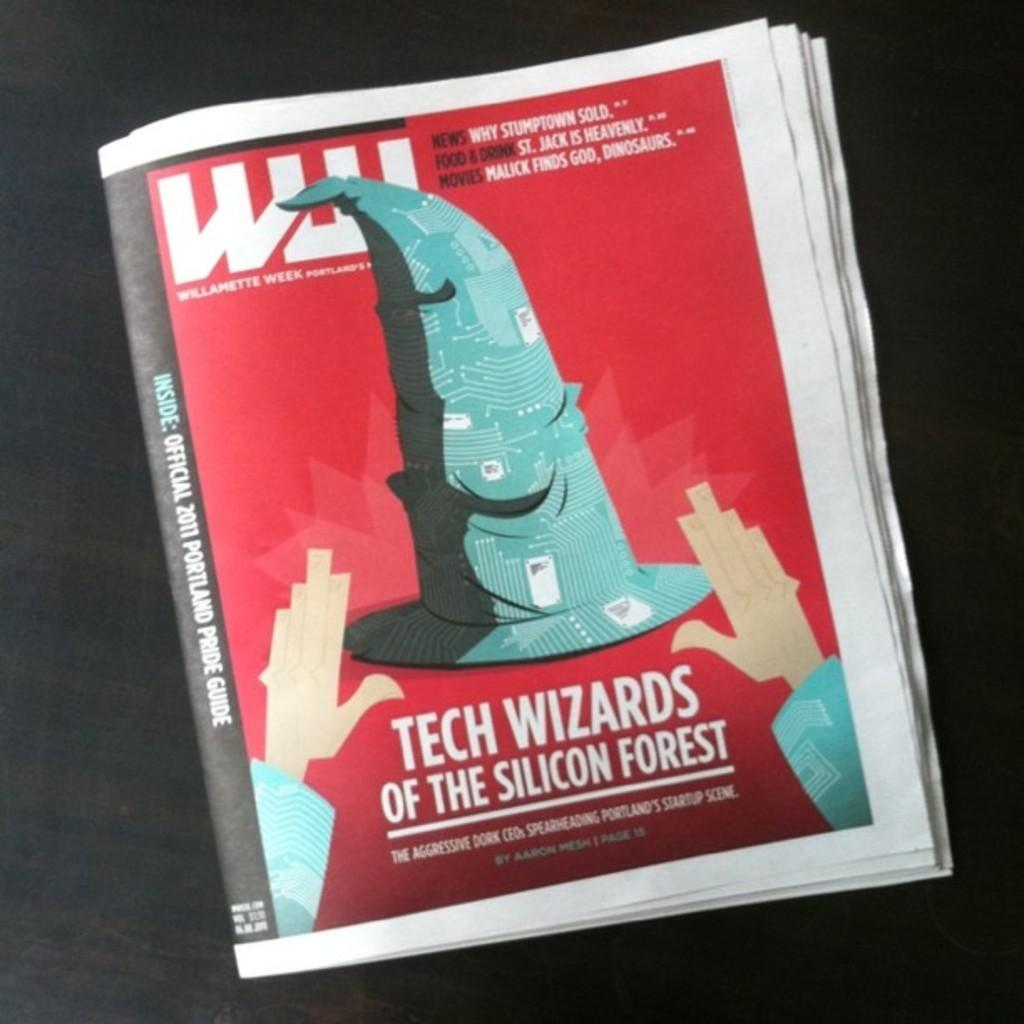Provide a one-sentence caption for the provided image. A looseleaf newspaper Williamette Week with the cover of Tech Wizards of Silicon Forest. 